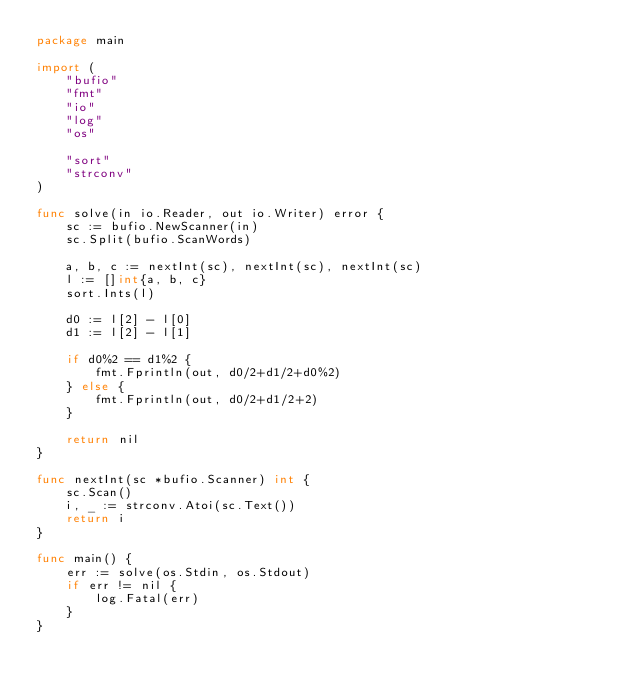<code> <loc_0><loc_0><loc_500><loc_500><_Go_>package main

import (
	"bufio"
	"fmt"
	"io"
	"log"
	"os"

	"sort"
	"strconv"
)

func solve(in io.Reader, out io.Writer) error {
	sc := bufio.NewScanner(in)
	sc.Split(bufio.ScanWords)

	a, b, c := nextInt(sc), nextInt(sc), nextInt(sc)
	l := []int{a, b, c}
	sort.Ints(l)

	d0 := l[2] - l[0]
	d1 := l[2] - l[1]

	if d0%2 == d1%2 {
		fmt.Fprintln(out, d0/2+d1/2+d0%2)
	} else {
		fmt.Fprintln(out, d0/2+d1/2+2)
	}

	return nil
}

func nextInt(sc *bufio.Scanner) int {
	sc.Scan()
	i, _ := strconv.Atoi(sc.Text())
	return i
}

func main() {
	err := solve(os.Stdin, os.Stdout)
	if err != nil {
		log.Fatal(err)
	}
}
</code> 